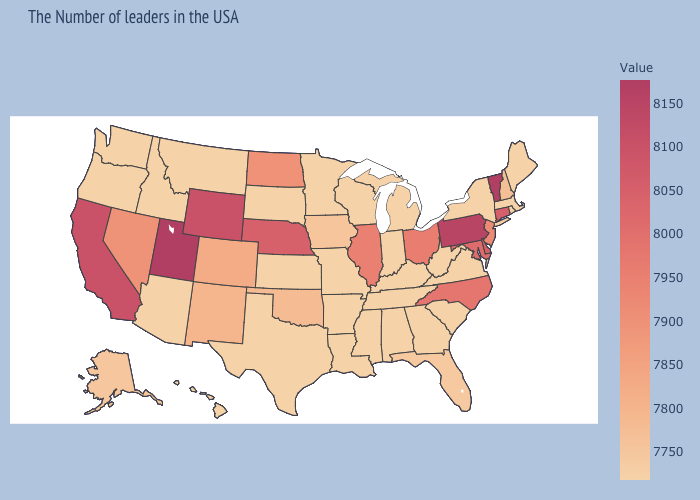Is the legend a continuous bar?
Be succinct. Yes. Does the map have missing data?
Be succinct. No. Does Wisconsin have a higher value than Ohio?
Concise answer only. No. Among the states that border California , does Oregon have the highest value?
Give a very brief answer. No. Among the states that border Maryland , does Pennsylvania have the highest value?
Concise answer only. Yes. 